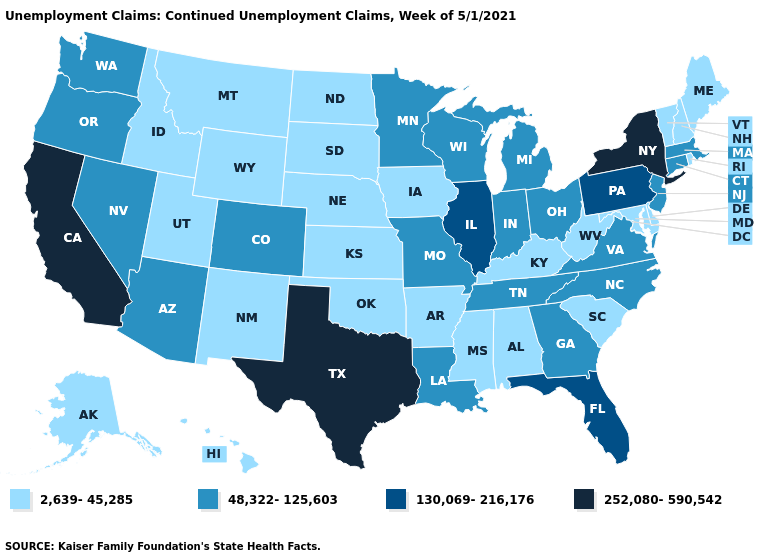Name the states that have a value in the range 252,080-590,542?
Short answer required. California, New York, Texas. What is the lowest value in the Northeast?
Keep it brief. 2,639-45,285. Name the states that have a value in the range 252,080-590,542?
Answer briefly. California, New York, Texas. Does Kansas have a higher value than Texas?
Concise answer only. No. Which states have the lowest value in the USA?
Give a very brief answer. Alabama, Alaska, Arkansas, Delaware, Hawaii, Idaho, Iowa, Kansas, Kentucky, Maine, Maryland, Mississippi, Montana, Nebraska, New Hampshire, New Mexico, North Dakota, Oklahoma, Rhode Island, South Carolina, South Dakota, Utah, Vermont, West Virginia, Wyoming. Among the states that border South Carolina , which have the lowest value?
Keep it brief. Georgia, North Carolina. What is the highest value in the USA?
Short answer required. 252,080-590,542. Among the states that border Arkansas , which have the lowest value?
Keep it brief. Mississippi, Oklahoma. What is the value of New Hampshire?
Keep it brief. 2,639-45,285. Name the states that have a value in the range 48,322-125,603?
Be succinct. Arizona, Colorado, Connecticut, Georgia, Indiana, Louisiana, Massachusetts, Michigan, Minnesota, Missouri, Nevada, New Jersey, North Carolina, Ohio, Oregon, Tennessee, Virginia, Washington, Wisconsin. What is the lowest value in the USA?
Write a very short answer. 2,639-45,285. Name the states that have a value in the range 252,080-590,542?
Answer briefly. California, New York, Texas. Name the states that have a value in the range 252,080-590,542?
Short answer required. California, New York, Texas. Does Massachusetts have a lower value than Pennsylvania?
Answer briefly. Yes. What is the value of Wyoming?
Give a very brief answer. 2,639-45,285. 